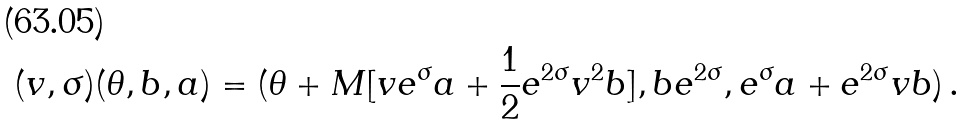<formula> <loc_0><loc_0><loc_500><loc_500>( v , \sigma ) ( \theta , b , a ) = ( \theta + M [ v e ^ { \sigma } a + \frac { 1 } { 2 } e ^ { 2 \sigma } v ^ { 2 } b ] , b e ^ { 2 \sigma } , e ^ { \sigma } a + e ^ { 2 \sigma } v b ) \, .</formula> 